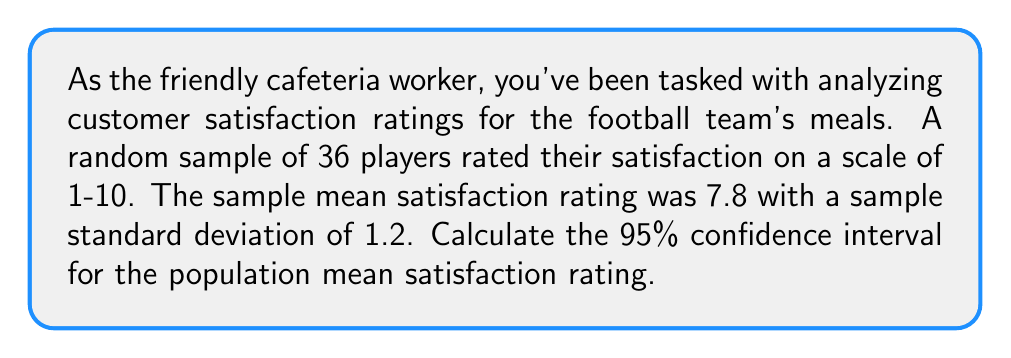Can you solve this math problem? Let's approach this step-by-step:

1) We're dealing with a confidence interval for a population mean with unknown population standard deviation. We'll use the t-distribution.

2) Given information:
   - Sample size: $n = 36$
   - Sample mean: $\bar{x} = 7.8$
   - Sample standard deviation: $s = 1.2$
   - Confidence level: 95%

3) The formula for the confidence interval is:

   $$\bar{x} \pm t_{\alpha/2} \cdot \frac{s}{\sqrt{n}}$$

4) We need to find $t_{\alpha/2}$ for a 95% confidence level with 35 degrees of freedom (df = n - 1 = 35).
   From t-distribution tables or calculator, we find: $t_{0.025, 35} \approx 2.030$

5) Now, let's calculate the margin of error:

   $$\text{Margin of Error} = t_{\alpha/2} \cdot \frac{s}{\sqrt{n}} = 2.030 \cdot \frac{1.2}{\sqrt{36}} \approx 0.406$$

6) The confidence interval is:

   $$7.8 \pm 0.406$$

7) Therefore, the 95% confidence interval is (7.394, 8.206).
Answer: (7.394, 8.206) 